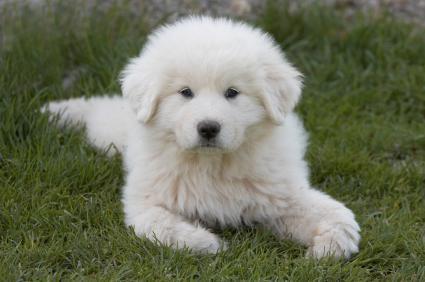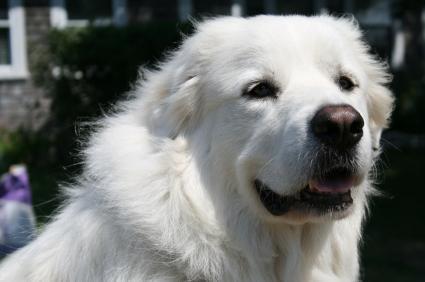The first image is the image on the left, the second image is the image on the right. For the images displayed, is the sentence "The right image has two dogs near each other." factually correct? Answer yes or no. No. 